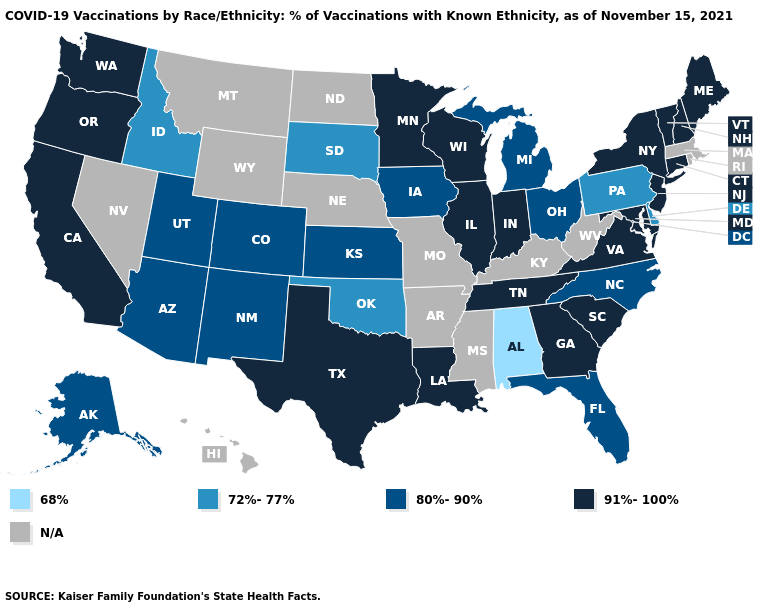Which states hav the highest value in the South?
Write a very short answer. Georgia, Louisiana, Maryland, South Carolina, Tennessee, Texas, Virginia. Name the states that have a value in the range 91%-100%?
Keep it brief. California, Connecticut, Georgia, Illinois, Indiana, Louisiana, Maine, Maryland, Minnesota, New Hampshire, New Jersey, New York, Oregon, South Carolina, Tennessee, Texas, Vermont, Virginia, Washington, Wisconsin. Name the states that have a value in the range 91%-100%?
Be succinct. California, Connecticut, Georgia, Illinois, Indiana, Louisiana, Maine, Maryland, Minnesota, New Hampshire, New Jersey, New York, Oregon, South Carolina, Tennessee, Texas, Vermont, Virginia, Washington, Wisconsin. What is the value of Kansas?
Keep it brief. 80%-90%. What is the value of New York?
Write a very short answer. 91%-100%. What is the lowest value in states that border Arizona?
Write a very short answer. 80%-90%. What is the value of Alaska?
Be succinct. 80%-90%. What is the value of Alaska?
Write a very short answer. 80%-90%. Among the states that border Georgia , which have the lowest value?
Give a very brief answer. Alabama. Does Florida have the lowest value in the South?
Quick response, please. No. Name the states that have a value in the range 91%-100%?
Concise answer only. California, Connecticut, Georgia, Illinois, Indiana, Louisiana, Maine, Maryland, Minnesota, New Hampshire, New Jersey, New York, Oregon, South Carolina, Tennessee, Texas, Vermont, Virginia, Washington, Wisconsin. Which states hav the highest value in the South?
Answer briefly. Georgia, Louisiana, Maryland, South Carolina, Tennessee, Texas, Virginia. What is the value of Wyoming?
Write a very short answer. N/A. What is the lowest value in the West?
Answer briefly. 72%-77%. 